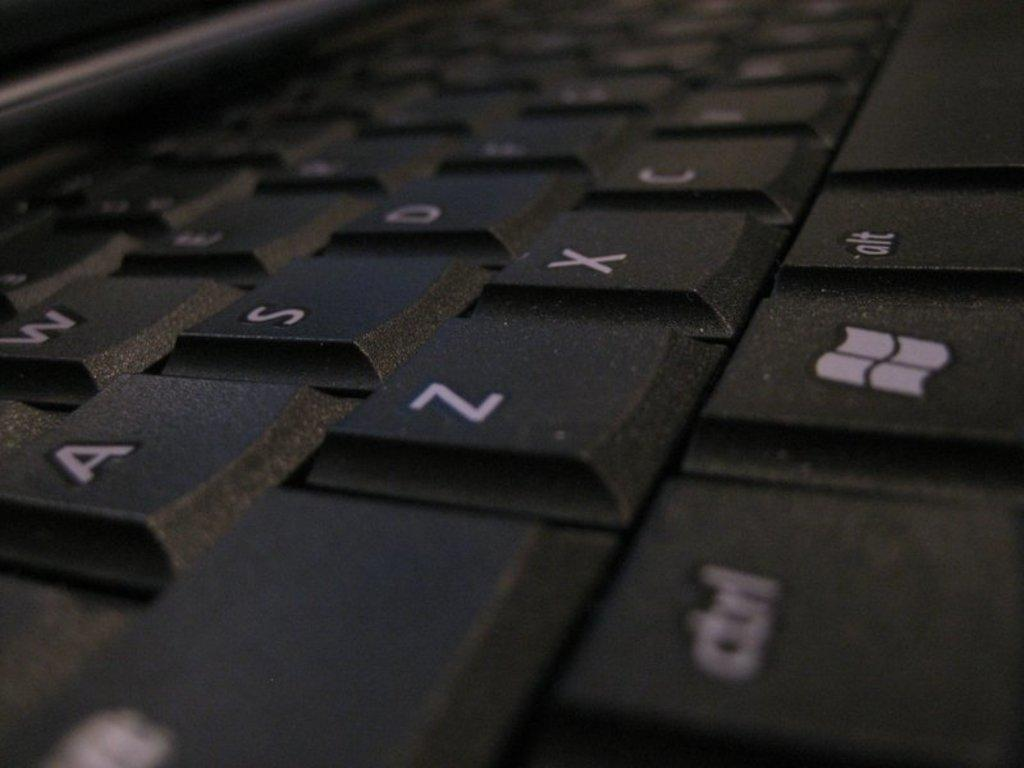<image>
Provide a brief description of the given image. a close up of a black key board with letters A, Z, and X 